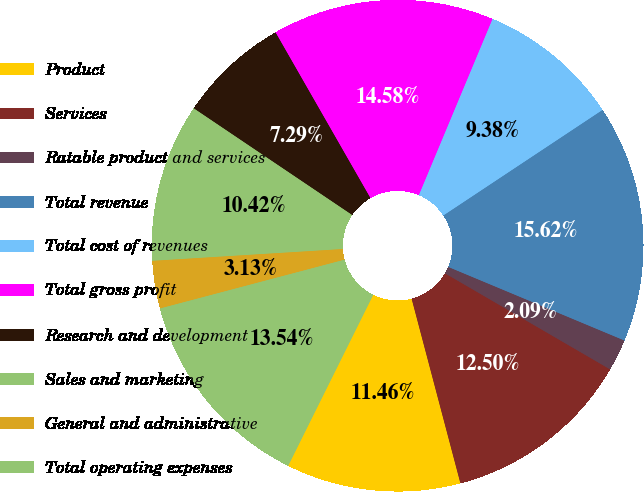<chart> <loc_0><loc_0><loc_500><loc_500><pie_chart><fcel>Product<fcel>Services<fcel>Ratable product and services<fcel>Total revenue<fcel>Total cost of revenues<fcel>Total gross profit<fcel>Research and development<fcel>Sales and marketing<fcel>General and administrative<fcel>Total operating expenses<nl><fcel>11.46%<fcel>12.5%<fcel>2.09%<fcel>15.62%<fcel>9.38%<fcel>14.58%<fcel>7.29%<fcel>10.42%<fcel>3.13%<fcel>13.54%<nl></chart> 